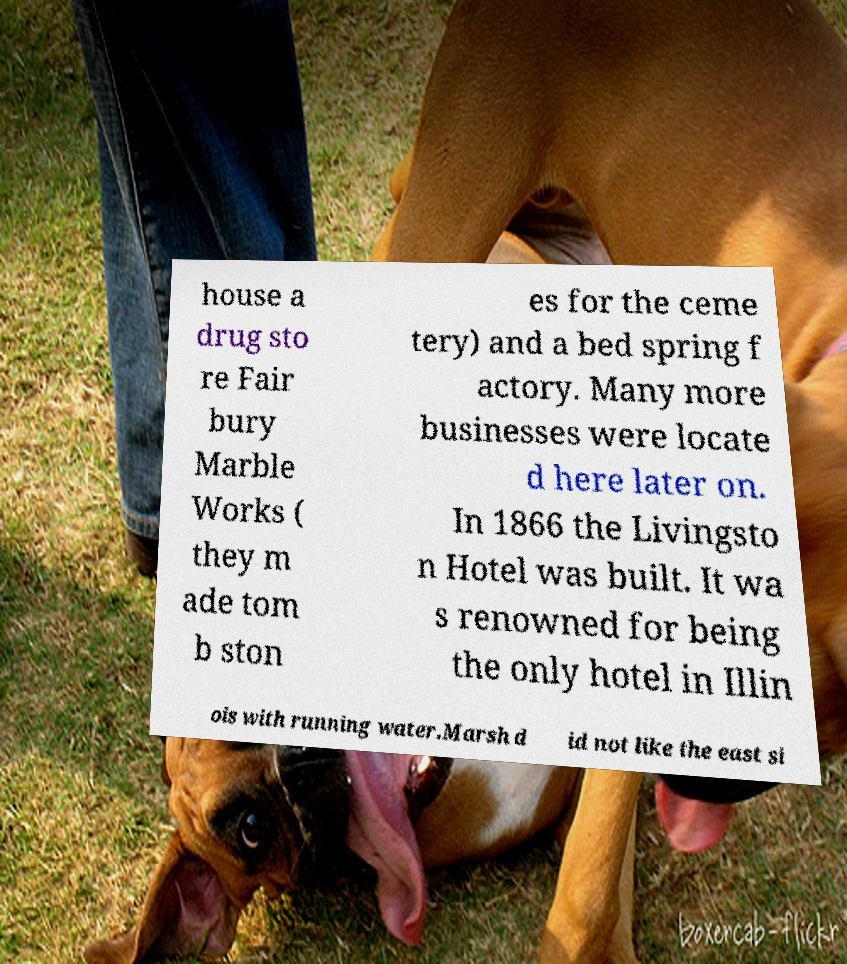Could you assist in decoding the text presented in this image and type it out clearly? house a drug sto re Fair bury Marble Works ( they m ade tom b ston es for the ceme tery) and a bed spring f actory. Many more businesses were locate d here later on. In 1866 the Livingsto n Hotel was built. It wa s renowned for being the only hotel in Illin ois with running water.Marsh d id not like the east si 